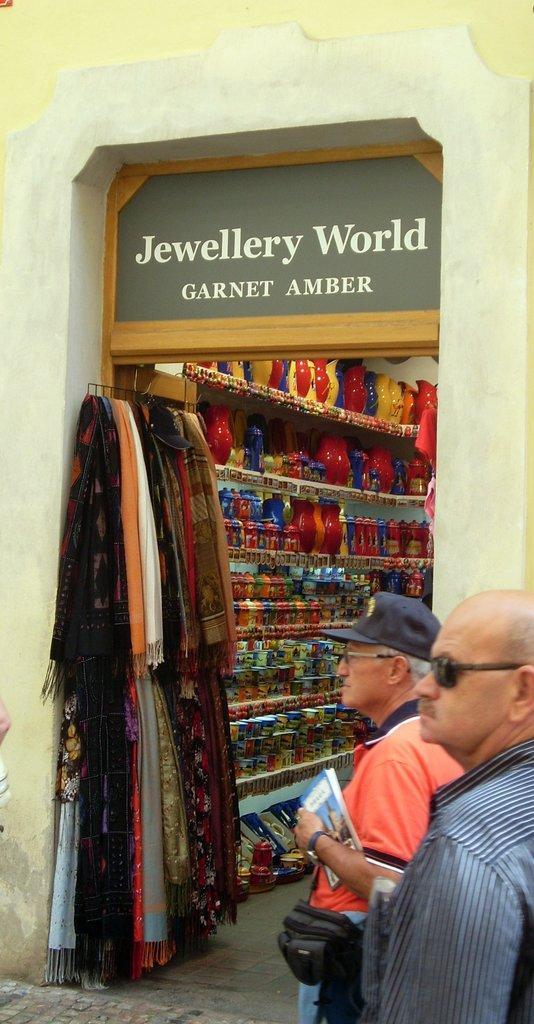How would you summarize this image in a sentence or two? In this picture we can see a store. We can see colorful objects arranged in the racks. Here we can see scarves. We can see two men wearing clothes and standing near to the store. This man wearing a cap, wrist watch and he is holding a book. 